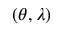<formula> <loc_0><loc_0><loc_500><loc_500>( \theta , \lambda )</formula> 